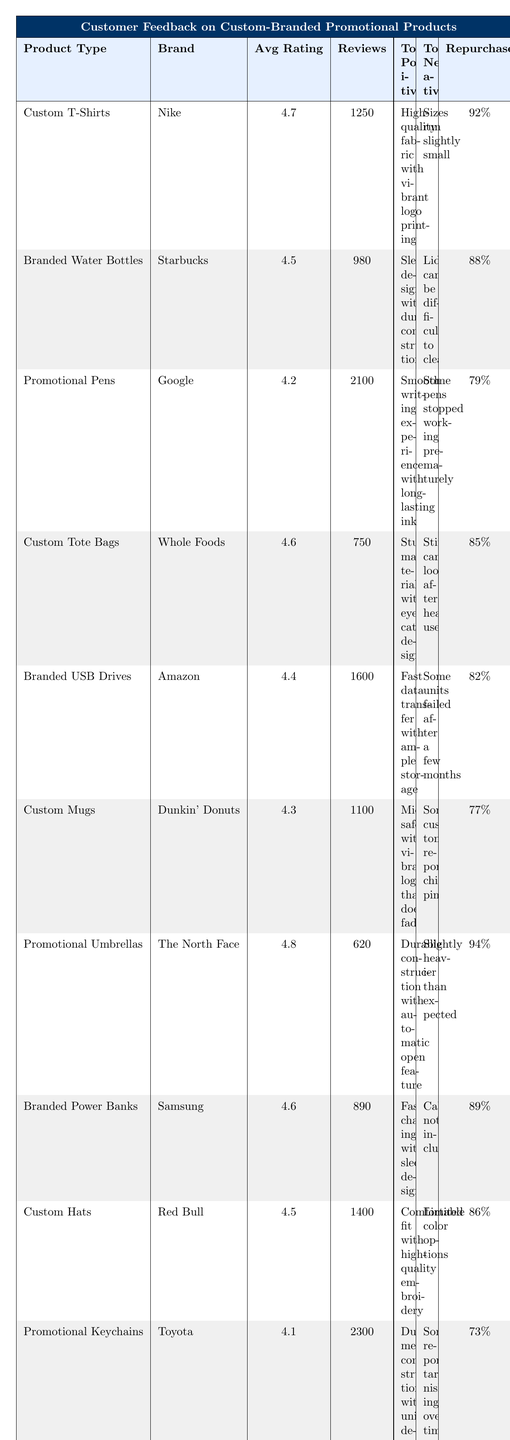What is the average rating for Custom T-Shirts? The table shows that the average rating for Custom T-Shirts under Nike is 4.7.
Answer: 4.7 Which product has the highest number of reviews? The table indicates that Promotional Keychains by Toyota have the highest reviews with 2300 reviews.
Answer: 2300 What is the repurchase intent percentage for Branded Water Bottles? According to the table, the repurchase intent percentage for Branded Water Bottles is 88%.
Answer: 88% Is the average rating of Custom Mugs higher than 4.5? The table states that the average rating for Custom Mugs is 4.3, which is not higher than 4.5.
Answer: No Which product has the top positive comment stating 'Durable construction with automatic open feature'? The table indicates that this top positive comment is for Promotional Umbrellas by The North Face.
Answer: Promotional Umbrellas What is the difference in average rating between Promotional Pens and Custom Tote Bags? The average rating for Promotional Pens is 4.2, and for Custom Tote Bags it is 4.6. The difference is 4.6 - 4.2 = 0.4.
Answer: 0.4 How many reviews do Branded Power Banks have? The table lists the number of reviews for Branded Power Banks as 890.
Answer: 890 What percentage of customers intend to repurchase Promotional Keychains? The table shows that the repurchase intent for Promotional Keychains is 73%.
Answer: 73% Which product received the top negative comment regarding "some reported tarnishing over time"? The table lists this comment for Promotional Keychains by Toyota.
Answer: Promotional Keychains What is the average rating of the products that have a repurchase intent of 90% or more? There are two products with 90% or more repurchase intent: Promotional Umbrellas (4.8) and Custom T-Shirts (4.7). The average is (4.8 + 4.7) / 2 = 4.75.
Answer: 4.75 